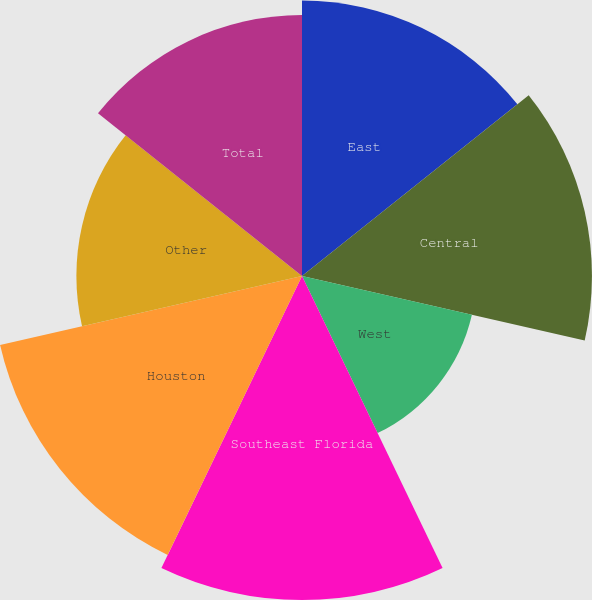Convert chart. <chart><loc_0><loc_0><loc_500><loc_500><pie_chart><fcel>East<fcel>Central<fcel>West<fcel>Southeast Florida<fcel>Houston<fcel>Other<fcel>Total<nl><fcel>14.81%<fcel>15.59%<fcel>9.37%<fcel>17.42%<fcel>16.65%<fcel>12.13%<fcel>14.03%<nl></chart> 